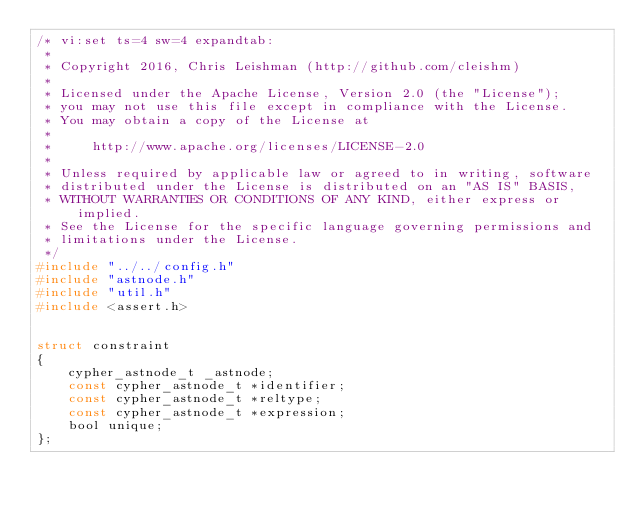Convert code to text. <code><loc_0><loc_0><loc_500><loc_500><_C_>/* vi:set ts=4 sw=4 expandtab:
 *
 * Copyright 2016, Chris Leishman (http://github.com/cleishm)
 *
 * Licensed under the Apache License, Version 2.0 (the "License");
 * you may not use this file except in compliance with the License.
 * You may obtain a copy of the License at
 *
 *     http://www.apache.org/licenses/LICENSE-2.0
 *
 * Unless required by applicable law or agreed to in writing, software
 * distributed under the License is distributed on an "AS IS" BASIS,
 * WITHOUT WARRANTIES OR CONDITIONS OF ANY KIND, either express or implied.
 * See the License for the specific language governing permissions and
 * limitations under the License.
 */
#include "../../config.h"
#include "astnode.h"
#include "util.h"
#include <assert.h>


struct constraint
{
    cypher_astnode_t _astnode;
    const cypher_astnode_t *identifier;
    const cypher_astnode_t *reltype;
    const cypher_astnode_t *expression;
    bool unique;
};

</code> 